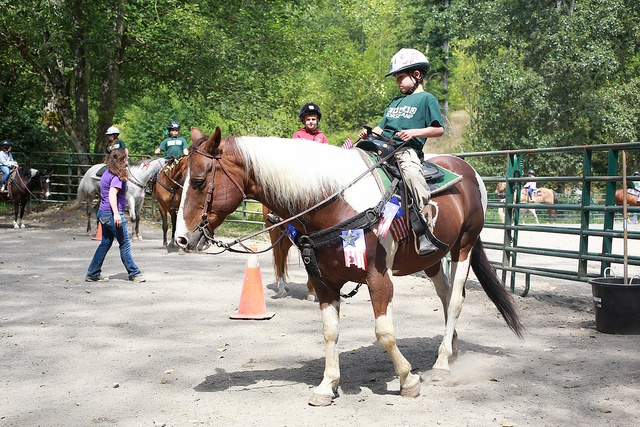Describe the objects in this image and their specific colors. I can see horse in darkgreen, white, black, brown, and gray tones, people in darkgreen, white, teal, black, and gray tones, people in darkgreen, black, navy, gray, and lightgray tones, horse in darkgreen, lightgray, gray, darkgray, and black tones, and horse in darkgreen, maroon, lightgray, darkgray, and black tones in this image. 